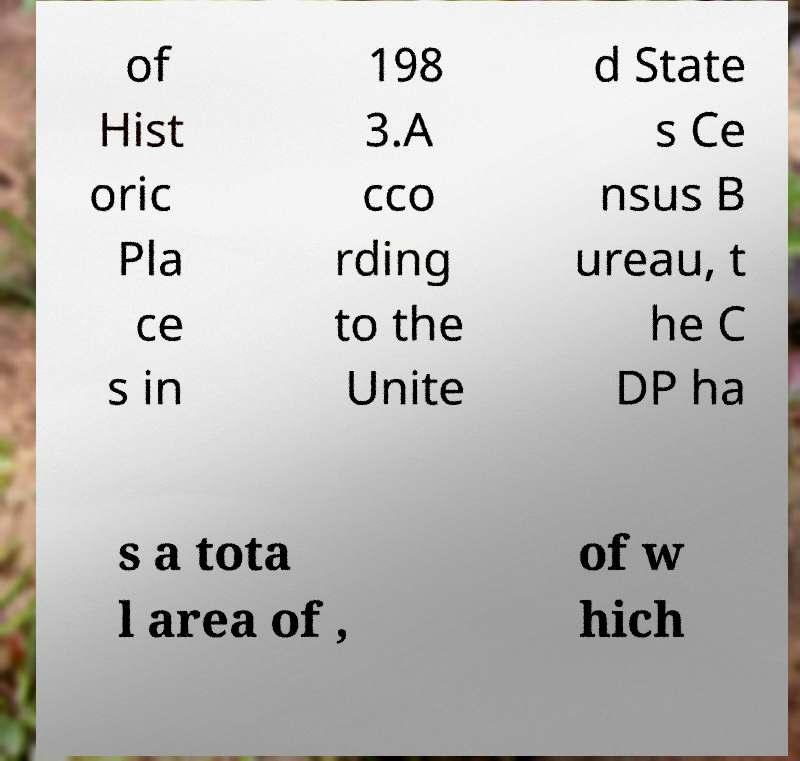Could you assist in decoding the text presented in this image and type it out clearly? of Hist oric Pla ce s in 198 3.A cco rding to the Unite d State s Ce nsus B ureau, t he C DP ha s a tota l area of , of w hich 